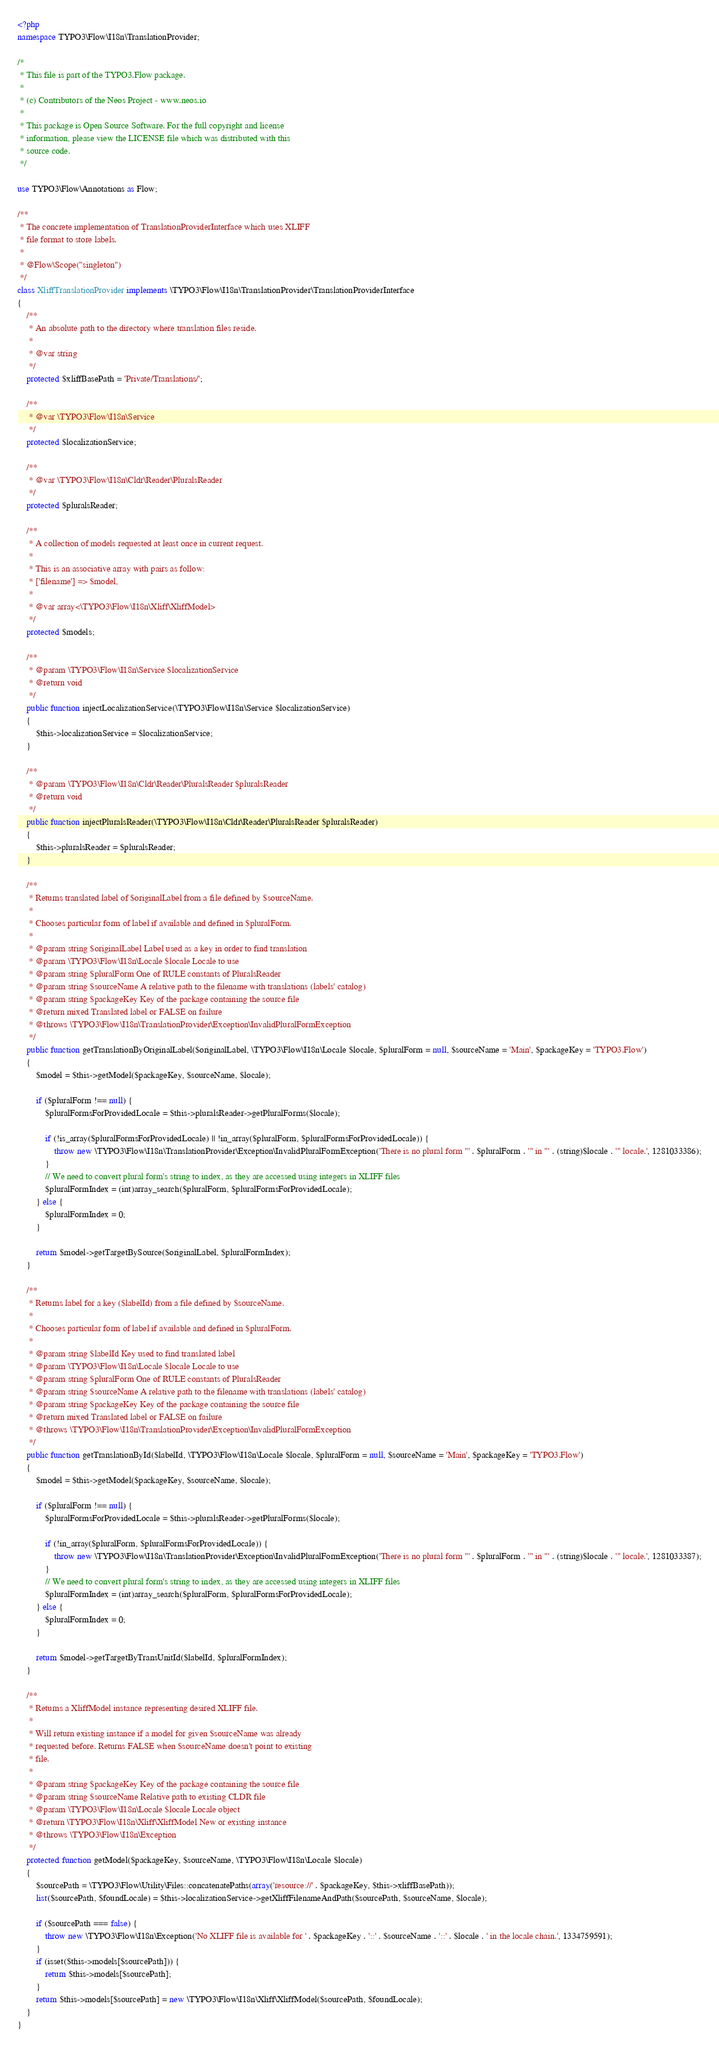<code> <loc_0><loc_0><loc_500><loc_500><_PHP_><?php
namespace TYPO3\Flow\I18n\TranslationProvider;

/*
 * This file is part of the TYPO3.Flow package.
 *
 * (c) Contributors of the Neos Project - www.neos.io
 *
 * This package is Open Source Software. For the full copyright and license
 * information, please view the LICENSE file which was distributed with this
 * source code.
 */

use TYPO3\Flow\Annotations as Flow;

/**
 * The concrete implementation of TranslationProviderInterface which uses XLIFF
 * file format to store labels.
 *
 * @Flow\Scope("singleton")
 */
class XliffTranslationProvider implements \TYPO3\Flow\I18n\TranslationProvider\TranslationProviderInterface
{
    /**
     * An absolute path to the directory where translation files reside.
     *
     * @var string
     */
    protected $xliffBasePath = 'Private/Translations/';

    /**
     * @var \TYPO3\Flow\I18n\Service
     */
    protected $localizationService;

    /**
     * @var \TYPO3\Flow\I18n\Cldr\Reader\PluralsReader
     */
    protected $pluralsReader;

    /**
     * A collection of models requested at least once in current request.
     *
     * This is an associative array with pairs as follow:
     * ['filename'] => $model,
     *
     * @var array<\TYPO3\Flow\I18n\Xliff\XliffModel>
     */
    protected $models;

    /**
     * @param \TYPO3\Flow\I18n\Service $localizationService
     * @return void
     */
    public function injectLocalizationService(\TYPO3\Flow\I18n\Service $localizationService)
    {
        $this->localizationService = $localizationService;
    }

    /**
     * @param \TYPO3\Flow\I18n\Cldr\Reader\PluralsReader $pluralsReader
     * @return void
     */
    public function injectPluralsReader(\TYPO3\Flow\I18n\Cldr\Reader\PluralsReader $pluralsReader)
    {
        $this->pluralsReader = $pluralsReader;
    }

    /**
     * Returns translated label of $originalLabel from a file defined by $sourceName.
     *
     * Chooses particular form of label if available and defined in $pluralForm.
     *
     * @param string $originalLabel Label used as a key in order to find translation
     * @param \TYPO3\Flow\I18n\Locale $locale Locale to use
     * @param string $pluralForm One of RULE constants of PluralsReader
     * @param string $sourceName A relative path to the filename with translations (labels' catalog)
     * @param string $packageKey Key of the package containing the source file
     * @return mixed Translated label or FALSE on failure
     * @throws \TYPO3\Flow\I18n\TranslationProvider\Exception\InvalidPluralFormException
     */
    public function getTranslationByOriginalLabel($originalLabel, \TYPO3\Flow\I18n\Locale $locale, $pluralForm = null, $sourceName = 'Main', $packageKey = 'TYPO3.Flow')
    {
        $model = $this->getModel($packageKey, $sourceName, $locale);

        if ($pluralForm !== null) {
            $pluralFormsForProvidedLocale = $this->pluralsReader->getPluralForms($locale);

            if (!is_array($pluralFormsForProvidedLocale) || !in_array($pluralForm, $pluralFormsForProvidedLocale)) {
                throw new \TYPO3\Flow\I18n\TranslationProvider\Exception\InvalidPluralFormException('There is no plural form "' . $pluralForm . '" in "' . (string)$locale . '" locale.', 1281033386);
            }
            // We need to convert plural form's string to index, as they are accessed using integers in XLIFF files
            $pluralFormIndex = (int)array_search($pluralForm, $pluralFormsForProvidedLocale);
        } else {
            $pluralFormIndex = 0;
        }

        return $model->getTargetBySource($originalLabel, $pluralFormIndex);
    }

    /**
     * Returns label for a key ($labelId) from a file defined by $sourceName.
     *
     * Chooses particular form of label if available and defined in $pluralForm.
     *
     * @param string $labelId Key used to find translated label
     * @param \TYPO3\Flow\I18n\Locale $locale Locale to use
     * @param string $pluralForm One of RULE constants of PluralsReader
     * @param string $sourceName A relative path to the filename with translations (labels' catalog)
     * @param string $packageKey Key of the package containing the source file
     * @return mixed Translated label or FALSE on failure
     * @throws \TYPO3\Flow\I18n\TranslationProvider\Exception\InvalidPluralFormException
     */
    public function getTranslationById($labelId, \TYPO3\Flow\I18n\Locale $locale, $pluralForm = null, $sourceName = 'Main', $packageKey = 'TYPO3.Flow')
    {
        $model = $this->getModel($packageKey, $sourceName, $locale);

        if ($pluralForm !== null) {
            $pluralFormsForProvidedLocale = $this->pluralsReader->getPluralForms($locale);

            if (!in_array($pluralForm, $pluralFormsForProvidedLocale)) {
                throw new \TYPO3\Flow\I18n\TranslationProvider\Exception\InvalidPluralFormException('There is no plural form "' . $pluralForm . '" in "' . (string)$locale . '" locale.', 1281033387);
            }
            // We need to convert plural form's string to index, as they are accessed using integers in XLIFF files
            $pluralFormIndex = (int)array_search($pluralForm, $pluralFormsForProvidedLocale);
        } else {
            $pluralFormIndex = 0;
        }

        return $model->getTargetByTransUnitId($labelId, $pluralFormIndex);
    }

    /**
     * Returns a XliffModel instance representing desired XLIFF file.
     *
     * Will return existing instance if a model for given $sourceName was already
     * requested before. Returns FALSE when $sourceName doesn't point to existing
     * file.
     *
     * @param string $packageKey Key of the package containing the source file
     * @param string $sourceName Relative path to existing CLDR file
     * @param \TYPO3\Flow\I18n\Locale $locale Locale object
     * @return \TYPO3\Flow\I18n\Xliff\XliffModel New or existing instance
     * @throws \TYPO3\Flow\I18n\Exception
     */
    protected function getModel($packageKey, $sourceName, \TYPO3\Flow\I18n\Locale $locale)
    {
        $sourcePath = \TYPO3\Flow\Utility\Files::concatenatePaths(array('resource://' . $packageKey, $this->xliffBasePath));
        list($sourcePath, $foundLocale) = $this->localizationService->getXliffFilenameAndPath($sourcePath, $sourceName, $locale);

        if ($sourcePath === false) {
            throw new \TYPO3\Flow\I18n\Exception('No XLIFF file is available for ' . $packageKey . '::' . $sourceName . '::' . $locale . ' in the locale chain.', 1334759591);
        }
        if (isset($this->models[$sourcePath])) {
            return $this->models[$sourcePath];
        }
        return $this->models[$sourcePath] = new \TYPO3\Flow\I18n\Xliff\XliffModel($sourcePath, $foundLocale);
    }
}
</code> 